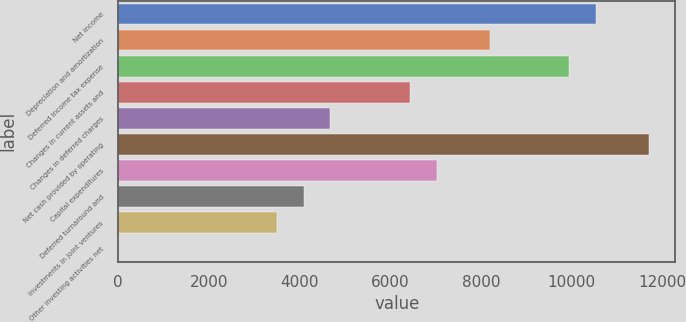Convert chart. <chart><loc_0><loc_0><loc_500><loc_500><bar_chart><fcel>Net income<fcel>Depreciation and amortization<fcel>Deferred income tax expense<fcel>Changes in current assets and<fcel>Changes in deferred charges<fcel>Net cash provided by operating<fcel>Capital expenditures<fcel>Deferred turnaround and<fcel>Investments in joint ventures<fcel>Other investing activities net<nl><fcel>10528.4<fcel>8189.2<fcel>9943.6<fcel>6434.8<fcel>4680.4<fcel>11698<fcel>7019.6<fcel>4095.6<fcel>3510.8<fcel>2<nl></chart> 